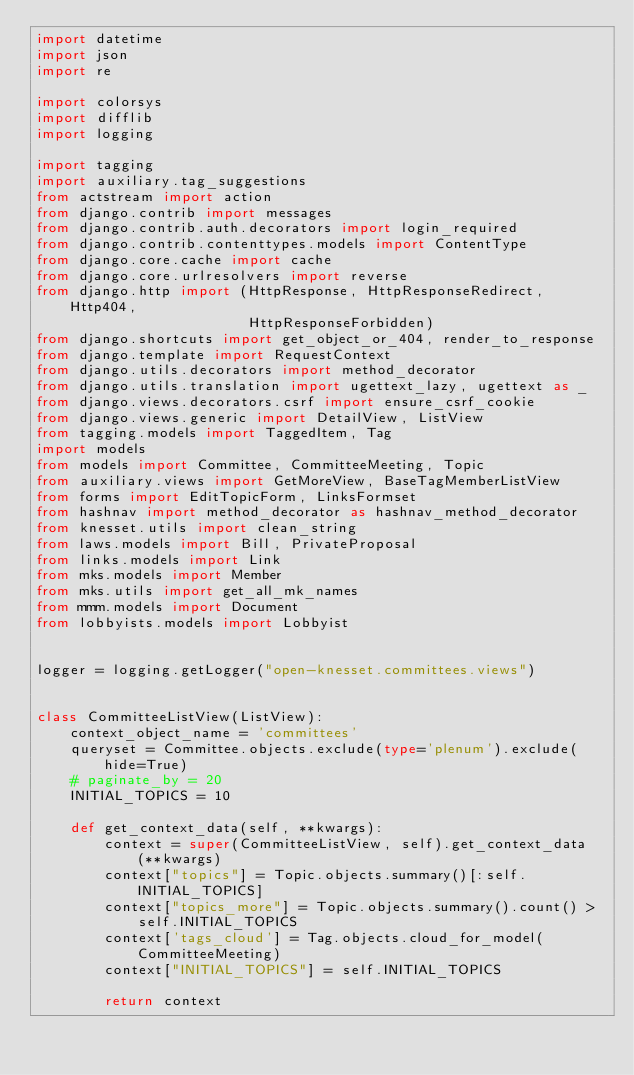<code> <loc_0><loc_0><loc_500><loc_500><_Python_>import datetime
import json
import re

import colorsys
import difflib
import logging

import tagging
import auxiliary.tag_suggestions
from actstream import action
from django.contrib import messages
from django.contrib.auth.decorators import login_required
from django.contrib.contenttypes.models import ContentType
from django.core.cache import cache
from django.core.urlresolvers import reverse
from django.http import (HttpResponse, HttpResponseRedirect, Http404,
                         HttpResponseForbidden)
from django.shortcuts import get_object_or_404, render_to_response
from django.template import RequestContext
from django.utils.decorators import method_decorator
from django.utils.translation import ugettext_lazy, ugettext as _
from django.views.decorators.csrf import ensure_csrf_cookie
from django.views.generic import DetailView, ListView
from tagging.models import TaggedItem, Tag
import models
from models import Committee, CommitteeMeeting, Topic
from auxiliary.views import GetMoreView, BaseTagMemberListView
from forms import EditTopicForm, LinksFormset
from hashnav import method_decorator as hashnav_method_decorator
from knesset.utils import clean_string
from laws.models import Bill, PrivateProposal
from links.models import Link
from mks.models import Member
from mks.utils import get_all_mk_names
from mmm.models import Document
from lobbyists.models import Lobbyist


logger = logging.getLogger("open-knesset.committees.views")


class CommitteeListView(ListView):
    context_object_name = 'committees'
    queryset = Committee.objects.exclude(type='plenum').exclude(hide=True)
    # paginate_by = 20
    INITIAL_TOPICS = 10

    def get_context_data(self, **kwargs):
        context = super(CommitteeListView, self).get_context_data(**kwargs)
        context["topics"] = Topic.objects.summary()[:self.INITIAL_TOPICS]
        context["topics_more"] = Topic.objects.summary().count() > self.INITIAL_TOPICS
        context['tags_cloud'] = Tag.objects.cloud_for_model(CommitteeMeeting)
        context["INITIAL_TOPICS"] = self.INITIAL_TOPICS

        return context

</code> 